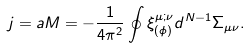<formula> <loc_0><loc_0><loc_500><loc_500>j = a M = - \frac { 1 } { 4 \pi ^ { 2 } } \oint \xi ^ { \mu ; \nu } _ { ( \phi ) } d ^ { N - 1 } \Sigma _ { \mu \nu } .</formula> 